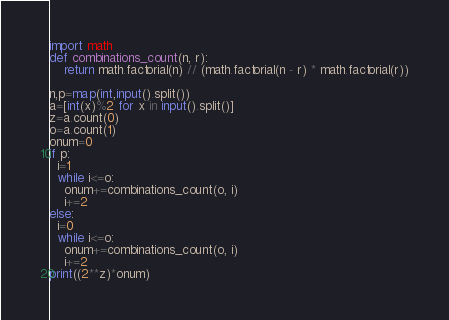Convert code to text. <code><loc_0><loc_0><loc_500><loc_500><_Python_>import math
def combinations_count(n, r):
    return math.factorial(n) // (math.factorial(n - r) * math.factorial(r))

n,p=map(int,input().split())
a=[int(x)%2 for x in input().split()]
z=a.count(0)
o=a.count(1)
onum=0
if p:
  i=1
  while i<=o:
    onum+=combinations_count(o, i)
    i+=2
else:
  i=0
  while i<=o:
    onum+=combinations_count(o, i)
    i+=2
print((2**z)*onum)</code> 